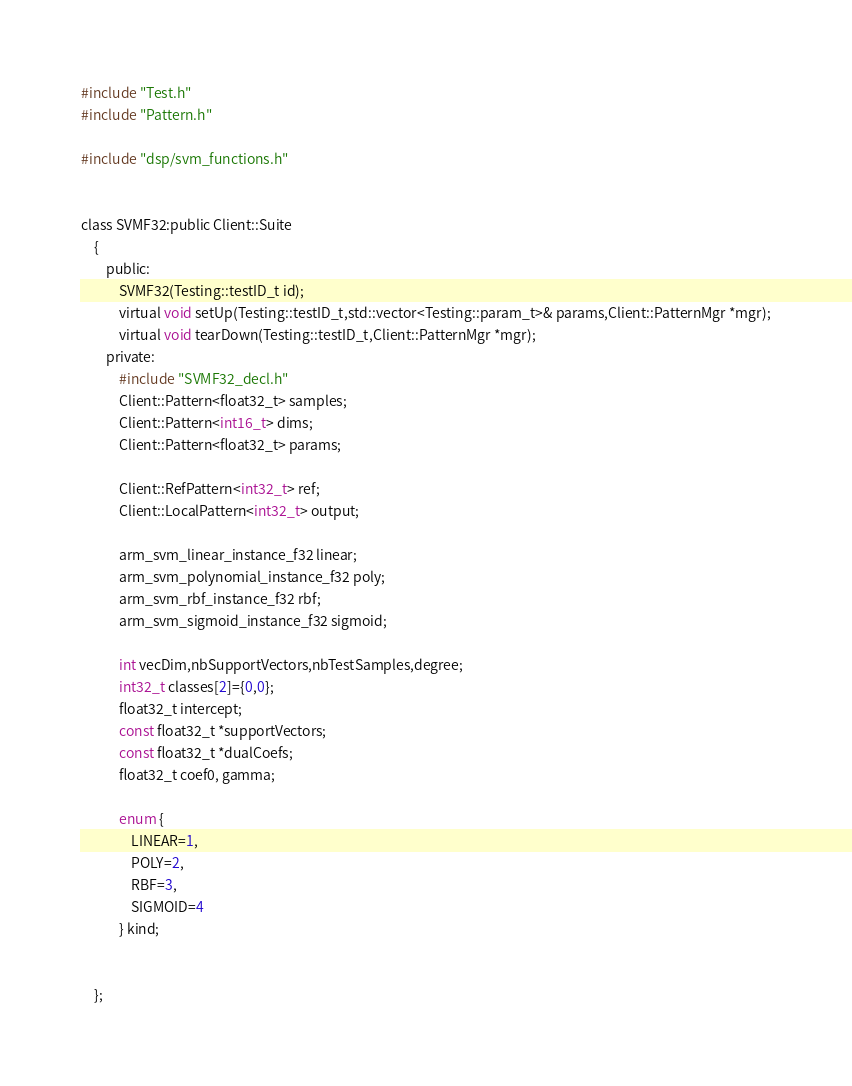<code> <loc_0><loc_0><loc_500><loc_500><_C_>#include "Test.h"
#include "Pattern.h"

#include "dsp/svm_functions.h"


class SVMF32:public Client::Suite
    {
        public:
            SVMF32(Testing::testID_t id);
            virtual void setUp(Testing::testID_t,std::vector<Testing::param_t>& params,Client::PatternMgr *mgr);
            virtual void tearDown(Testing::testID_t,Client::PatternMgr *mgr);
        private:
            #include "SVMF32_decl.h"
            Client::Pattern<float32_t> samples;
            Client::Pattern<int16_t> dims;
            Client::Pattern<float32_t> params;

            Client::RefPattern<int32_t> ref;
            Client::LocalPattern<int32_t> output;

            arm_svm_linear_instance_f32 linear;
            arm_svm_polynomial_instance_f32 poly;
            arm_svm_rbf_instance_f32 rbf;
            arm_svm_sigmoid_instance_f32 sigmoid;

            int vecDim,nbSupportVectors,nbTestSamples,degree;
            int32_t classes[2]={0,0};
            float32_t intercept;
            const float32_t *supportVectors;
            const float32_t *dualCoefs;
            float32_t coef0, gamma;

            enum {
                LINEAR=1,
                POLY=2,
                RBF=3,
                SIGMOID=4
            } kind;

            
    };
</code> 